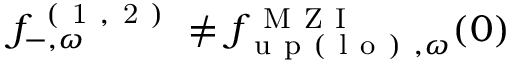<formula> <loc_0><loc_0><loc_500><loc_500>f _ { - , \omega } ^ { ( 1 , 2 ) } \neq { f } _ { u p ( l o ) , \omega } ^ { M Z I } ( 0 )</formula> 